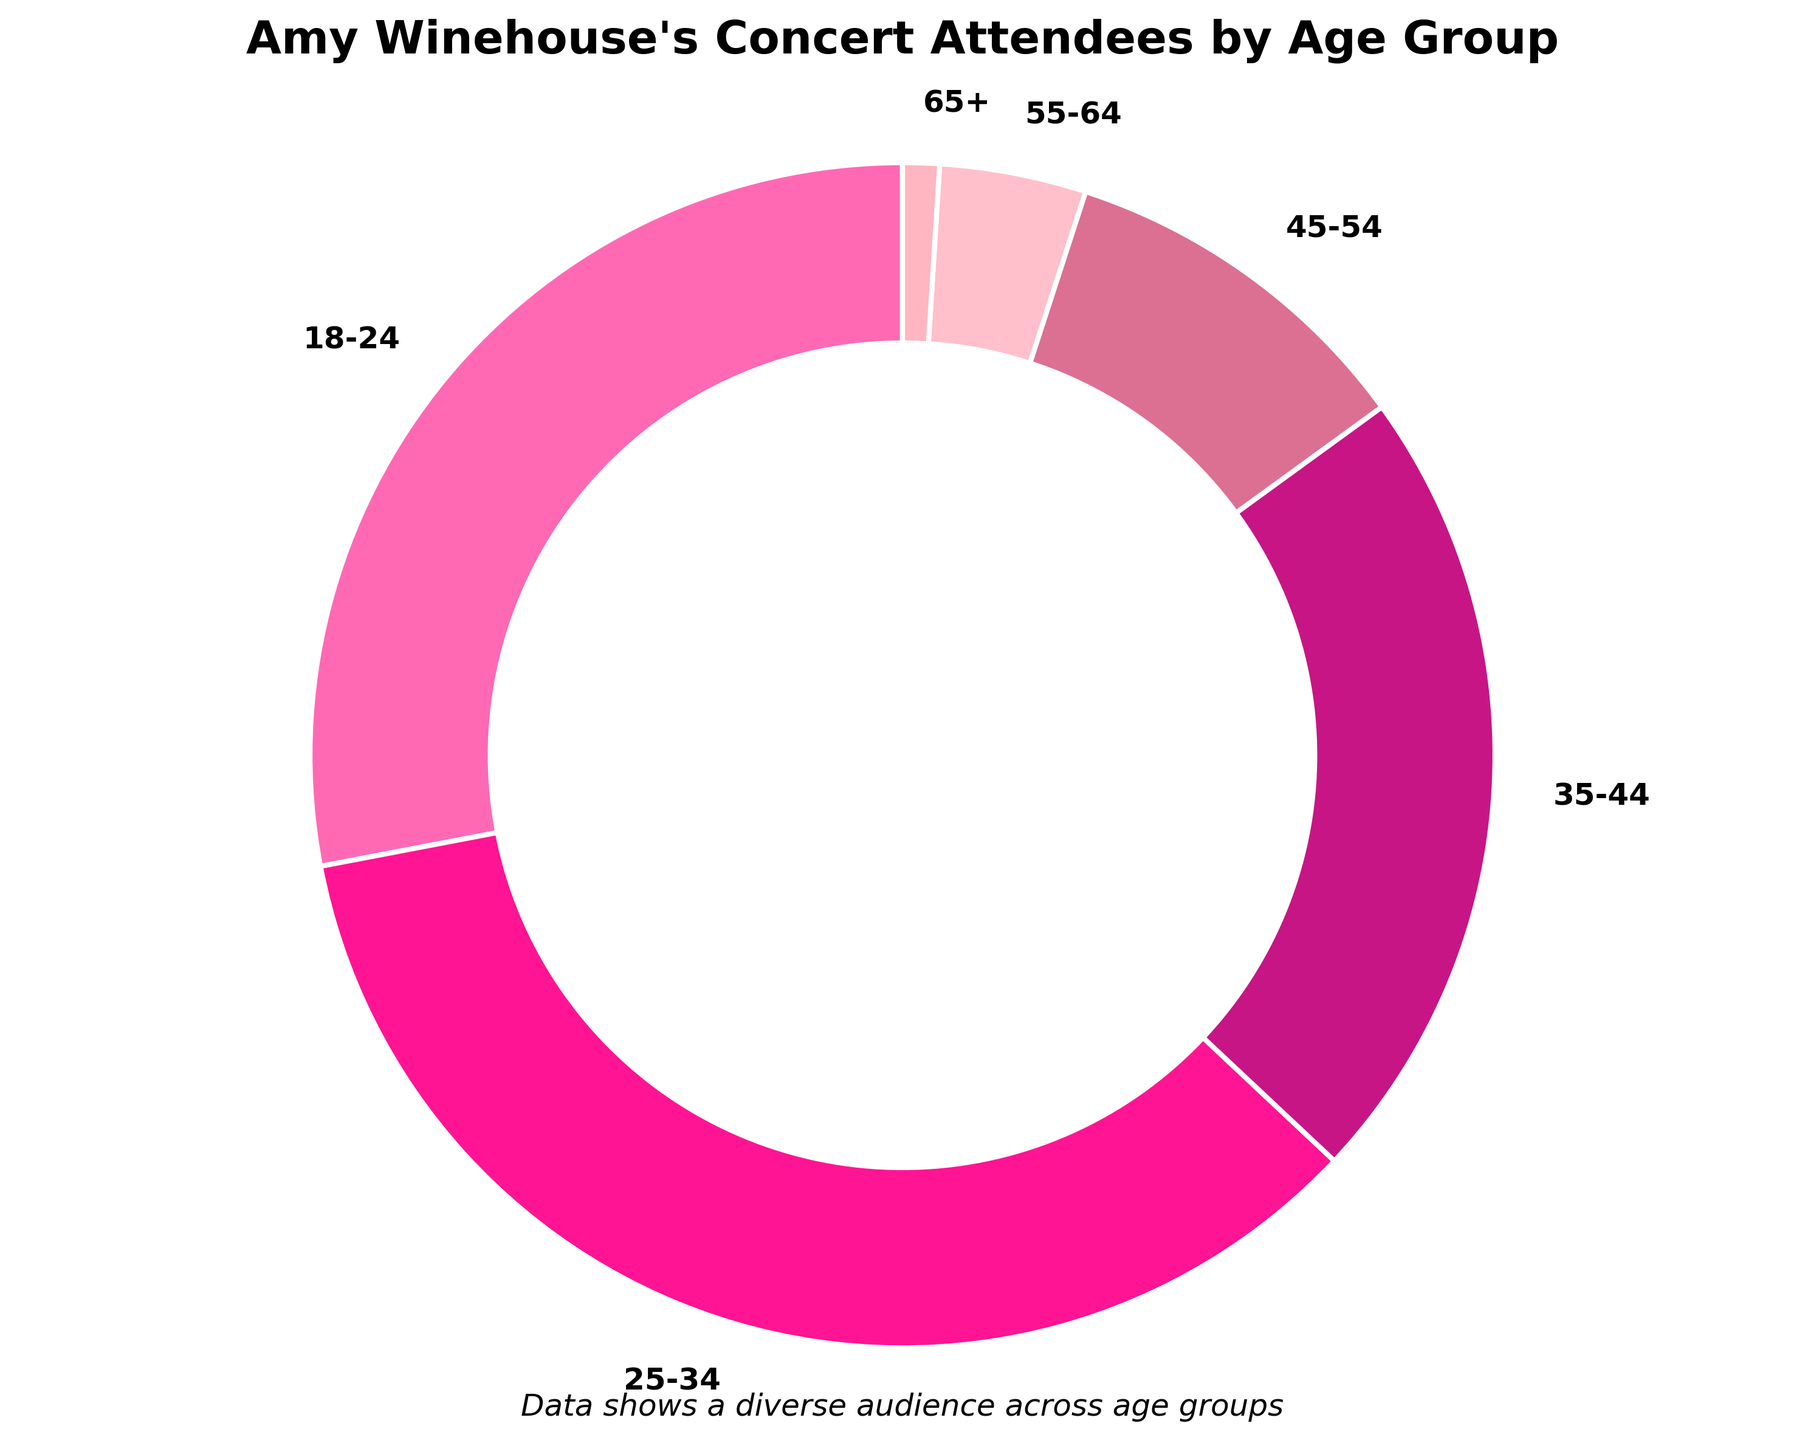Which age group has the highest percentage of concert attendees? By looking at the pie chart, the age group with the largest slice will indicate the highest percentage. The 25-34 age group has the biggest slice.
Answer: 25-34 Which two age groups combined represent more than half of the concert attendees? To find this, we look for the two biggest slices and sum their percentages. The 25-34 age group is 35% and the 18-24 age group is 28%. Adding them together, 35% + 28% = 63%, which is more than half.
Answer: 18-24 and 25-34 What is the percentage difference between the 25-34 age group and the 35-44 age group? First, identify the percentages for each age group from the chart: 25-34 is 35%, and 35-44 is 22%. Subtract the smaller percentage from the larger one: 35% - 22% = 13%.
Answer: 13% How many age groups represent less than 10% of the concert attendees each? From the pie chart, we note the percentages: 45-54 (10%), 55-64 (4%), and 65+ (1%). There are three age groups under 10%.
Answer: 3 Which age group has the smallest percentage of concert attendees, and what color is its slice? The slice that is the smallest in the pie chart represents the age group with 1%, which is 65+. The color of this slice is observed to be light pink.
Answer: 65+, light pink Is the percentage of attendees aged 18-24 higher than those aged 35-44? Compare the slices for the 18-24 and 35-44 age groups. The 18-24 group has 28%, while the 35-44 group has 22%. Since 28% is greater than 22%, the 18-24 group is higher.
Answer: Yes What is the combined percentage of concert attendees over the age of 44? Identify the percentages for age groups over 44: 45-54 (10%), 55-64 (4%), and 65+ (1%). Then sum these percentages: 10% + 4% + 1% = 15%.
Answer: 15% Among the age groups 35-44 and 45-54, which group has nearly double the percentage of the other? The percentage for the 35-44 age group is 22%, and for the 45-54 age group, it is 10%. Since doubling 10% gives us 20%, which is close to 22%, the 35-44 age group has nearly double the percentage of the 45-54 age group.
Answer: 35-44 What is the percentage sum of the three smallest age groups? Identify the smallest age groups and their percentages: 55-64 (4%) and 65+ (1%), as well as 45-54 (10%). Sum the percentages: 4% + 1% + 10% = 15%.
Answer: 15% What visual element makes the center of the pie chart different from a typical pie chart? Observing the pie chart, a white circle has been added to the center, making it look like a donut chart. This circle differentiates it from a typical pie chart.
Answer: White circle 